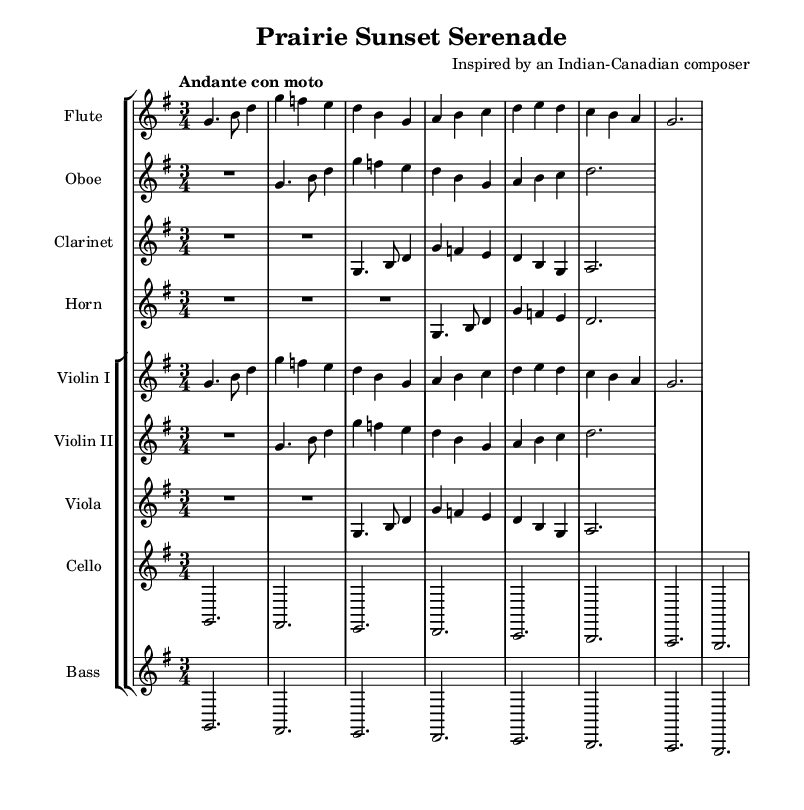What is the title of this piece? The title is found in the header section of the sheet music, specifically labeled as "title". In this case, it reads "Prairie Sunset Serenade".
Answer: Prairie Sunset Serenade What is the time signature of this music? The time signature is indicated at the beginning of the sheet music, after the key signature. Here, it is shown as 3/4, meaning there are three beats in a measure and the quarter note receives one beat.
Answer: 3/4 Who is the composer of this symphony? The composer is named in the header section of the sheet music, which states "Inspired by an Indian-Canadian composer". This gives credit to the composer involved.
Answer: Inspired by an Indian-Canadian composer What tempo marking is indicated for this symphony? The tempo marking appears right above the staff in the global settings and is stated as "Andante con moto", which suggests a moderately slow tempo with some movement.
Answer: Andante con moto How many instruments are featured in this symphony? To find the number of instruments, I can count the individual staves in the score section. There are a total of eight staves, each representing a different instrument part in the symphony.
Answer: Eight Which instrument has a transposition indicated? The instrument labeled "Clarinet" shows a transposition of B flat. This is indicated by the term "transposition bes" in the corresponding musical line under that instrument.
Answer: Clarinet Is there any rest indicated in the first section for the horn? Yes, the first section for the horn does include rests, which are denoted by the "R" symbol. There are three measures of rests at the beginning before the first note plays.
Answer: Yes 